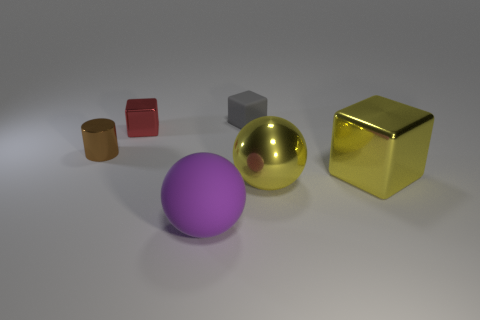Can you tell me about the largest object in the image? Certainly! The largest object in the image is a golden sphere. It has a shiny, reflective surface and is centrally positioned among the collection of smaller geometric shapes. 